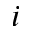<formula> <loc_0><loc_0><loc_500><loc_500>i</formula> 